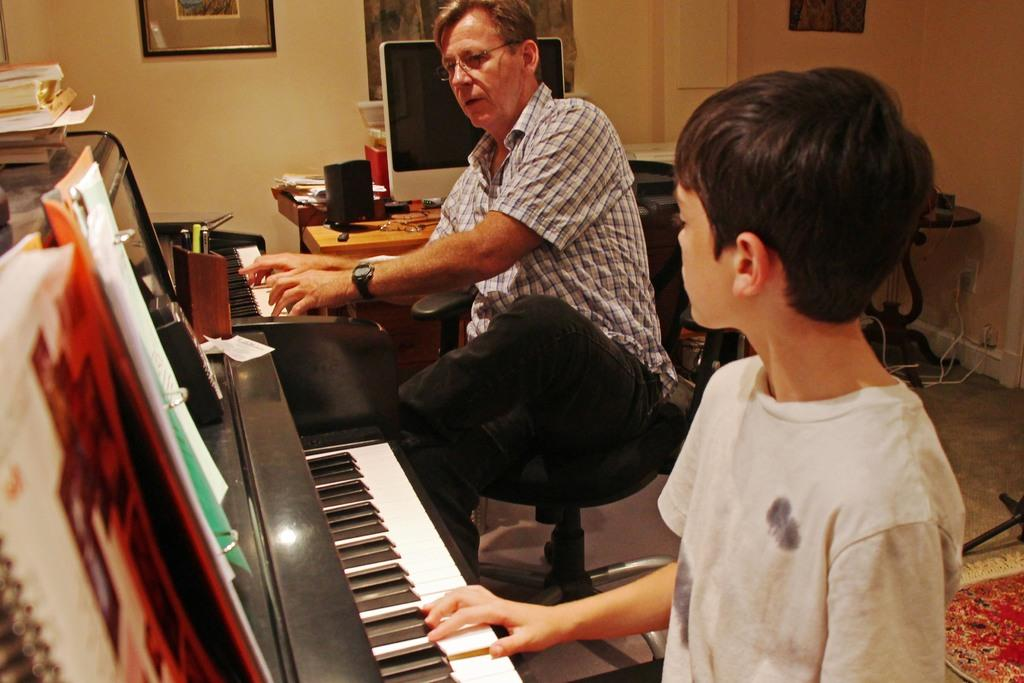What is hanging on the wall in the image? There are frames on a wall in the image. What are the man and the boy doing in the image? The man and the boy are sitting on chairs and playing a musical keyboard. What items can be seen on the table in the image? There are books, speakers, and a monitor on the table in the image. On what surface are the man, the boy, and the table located? The scene takes place on a floor. What type of tub is visible in the image? There is no tub present in the image. What is the man and the boy protesting in the image? There is no protest or any indication of protest in the image. 